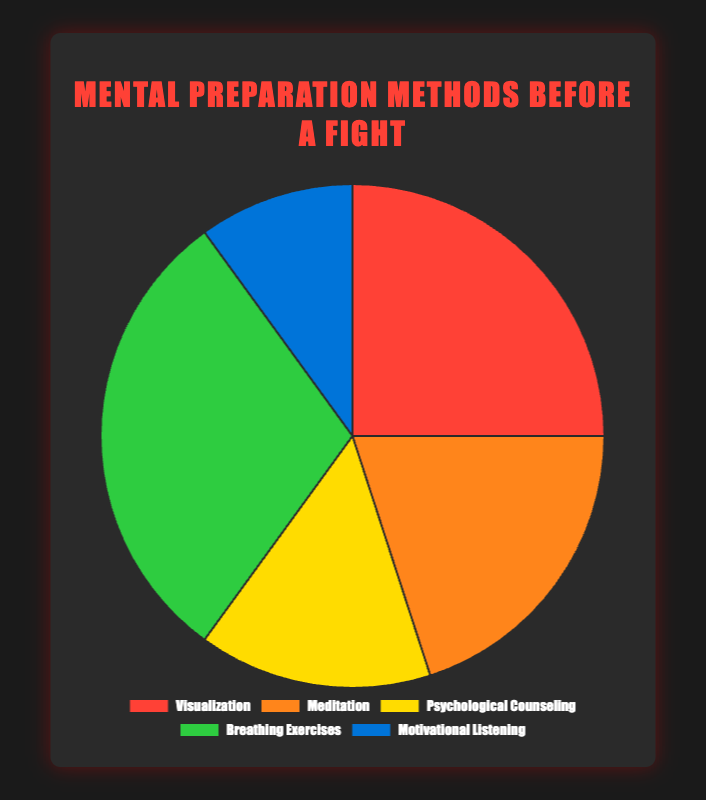What mental preparation method has the smallest percentage? We look at the given data: Visualization (25%), Meditation (20%), Psychological Counseling (15%), Breathing Exercises (30%), Motivational Listening (10%). The smallest percentage is clearly Motivational Listening at 10%.
Answer: Motivational Listening What percent of fighters use either Visualization or Meditation for mental preparation? Add the percentages of Visualization (25%) and Meditation (20%). 25% + 20% = 45%.
Answer: 45% Which two methods combined have the largest percentage of usage? The possible pairs are: Visualization + Meditation (25% + 20% = 45%), Visualization + Psychological Counseling (25% + 15% = 40%), Visualization + Breathing Exercises (25% + 30% = 55%), Visualization + Motivational Listening (25% + 10% = 35%), Meditation + Psychological Counseling (20% + 15% = 35%), Meditation + Breathing Exercises (20% + 30% = 50%), Meditation + Motivational Listening (20% + 10% = 30%), Psychological Counseling + Breathing Exercises (15% + 30% = 45%), Psychological Counseling + Motivational Listening (15% + 10% = 25%), Breathing Exercises + Motivational Listening (30% + 10% = 40%). The pair with the largest percentage is Visualization + Breathing Exercises with 55%.
Answer: Visualization and Breathing Exercises What is the average percentage of all the mental preparation methods? To find the average, sum up all the percentages and divide by the number of methods. (25% + 20% + 15% + 30% + 10%) / 5 = 100% / 5 = 20%.
Answer: 20% What is the difference in usage percentage between the method with the highest usage and the method with the lowest usage? The highest usage is Breathing Exercises at 30%, and the lowest usage is Motivational Listening at 10%. The difference is 30% - 10% = 20%.
Answer: 20% Which method is represented by the green color in the pie chart? In the dataset provided, the green color is associated with the Breathing Exercises usage percentage of 30%.
Answer: Breathing Exercises Which mental preparation methods have usage percentages greater than 15% but less than 30%? Referring to the provided data, Visualization (25%), Meditation (20%), and Breathing Exercises (30%). The methods in the range are Visualization and Meditation.
Answer: Visualization and Meditation By what percentage does the usage of Breathing Exercises exceed the usage of Psychological Counseling? The percentage usage of Breathing Exercises is 30%, and Psychological Counseling is 15%. The difference is 30% - 15% = 15%.
Answer: 15% If 100 fighters use these methods, how many would use Visualization or Psychological Counseling? We combine the percentages for Visualization (25%) and Psychological Counseling (15%). Thus, 25% + 15% = 40%. Therefore, 40% of 100 fighters is 40 fighters.
Answer: 40 fighters 